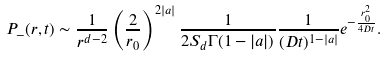<formula> <loc_0><loc_0><loc_500><loc_500>P _ { - } ( r , t ) \sim \frac { 1 } { r ^ { d - 2 } } \left ( \frac { 2 } { r _ { 0 } } \right ) ^ { 2 | a | } \frac { 1 } { 2 S _ { d } \Gamma ( 1 - | a | ) } \frac { 1 } { ( D t ) ^ { 1 - | a | } } e ^ { - \frac { r _ { 0 } ^ { 2 } } { 4 D t } } .</formula> 